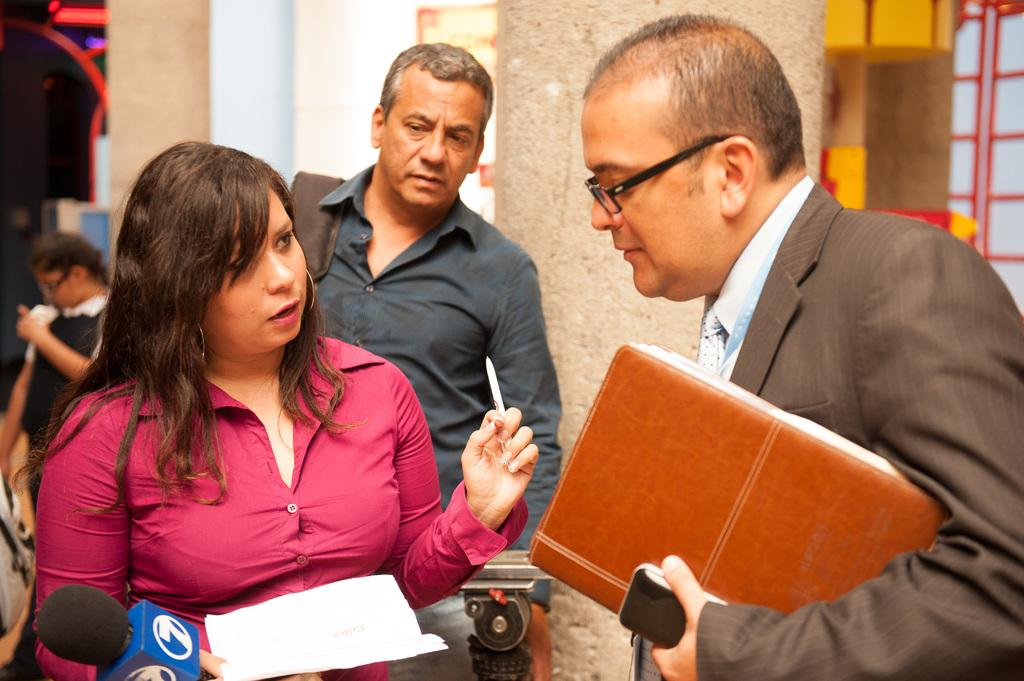What types of people are in the image? There are men and women in the image. Where are the men and women positioned in the image? The men and women are standing in the front. What are the men and women holding in the image? The men and women are holding microphones and files. What can be seen in the background of the image? There is a wall in the background of the image. What type of drawer can be seen in the image? There is no drawer present in the image. How is the string used by the men and women in the image? There is no string present in the image. 